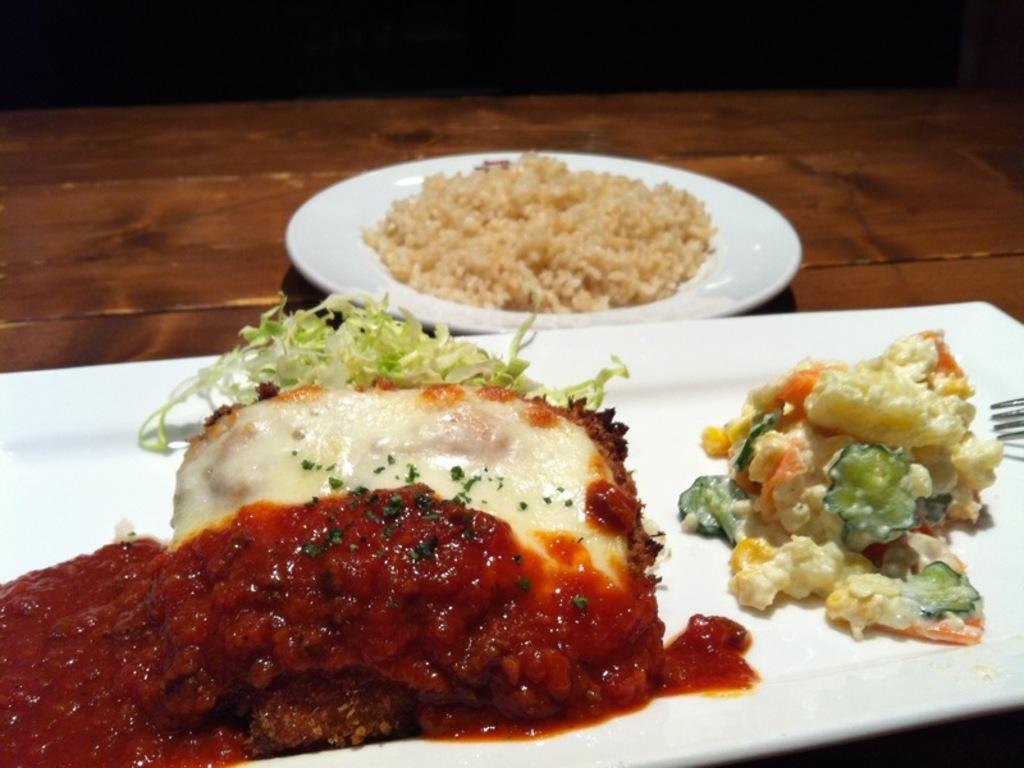Please provide a concise description of this image. In this image I see white plates on which there is food which is of red, green, orange and cream in color and I see the fork over here and these 2 plates are on the brown surface and it is dark over here. 